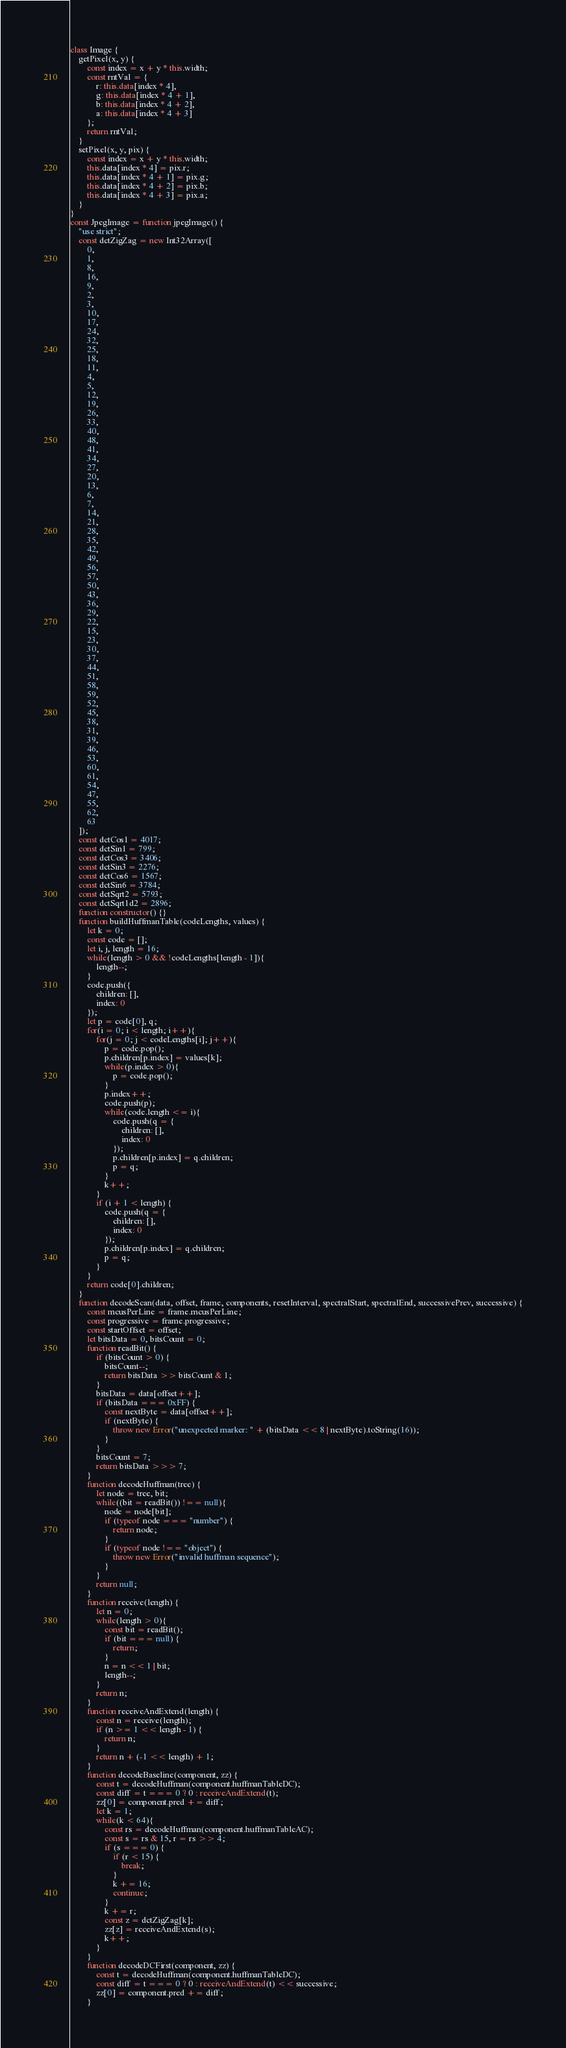Convert code to text. <code><loc_0><loc_0><loc_500><loc_500><_TypeScript_>class Image {
    getPixel(x, y) {
        const index = x + y * this.width;
        const rntVal = {
            r: this.data[index * 4],
            g: this.data[index * 4 + 1],
            b: this.data[index * 4 + 2],
            a: this.data[index * 4 + 3]
        };
        return rntVal;
    }
    setPixel(x, y, pix) {
        const index = x + y * this.width;
        this.data[index * 4] = pix.r;
        this.data[index * 4 + 1] = pix.g;
        this.data[index * 4 + 2] = pix.b;
        this.data[index * 4 + 3] = pix.a;
    }
}
const JpegImage = function jpegImage() {
    "use strict";
    const dctZigZag = new Int32Array([
        0,
        1,
        8,
        16,
        9,
        2,
        3,
        10,
        17,
        24,
        32,
        25,
        18,
        11,
        4,
        5,
        12,
        19,
        26,
        33,
        40,
        48,
        41,
        34,
        27,
        20,
        13,
        6,
        7,
        14,
        21,
        28,
        35,
        42,
        49,
        56,
        57,
        50,
        43,
        36,
        29,
        22,
        15,
        23,
        30,
        37,
        44,
        51,
        58,
        59,
        52,
        45,
        38,
        31,
        39,
        46,
        53,
        60,
        61,
        54,
        47,
        55,
        62,
        63
    ]);
    const dctCos1 = 4017;
    const dctSin1 = 799;
    const dctCos3 = 3406;
    const dctSin3 = 2276;
    const dctCos6 = 1567;
    const dctSin6 = 3784;
    const dctSqrt2 = 5793;
    const dctSqrt1d2 = 2896;
    function constructor() {}
    function buildHuffmanTable(codeLengths, values) {
        let k = 0;
        const code = [];
        let i, j, length = 16;
        while(length > 0 && !codeLengths[length - 1]){
            length--;
        }
        code.push({
            children: [],
            index: 0
        });
        let p = code[0], q;
        for(i = 0; i < length; i++){
            for(j = 0; j < codeLengths[i]; j++){
                p = code.pop();
                p.children[p.index] = values[k];
                while(p.index > 0){
                    p = code.pop();
                }
                p.index++;
                code.push(p);
                while(code.length <= i){
                    code.push(q = {
                        children: [],
                        index: 0
                    });
                    p.children[p.index] = q.children;
                    p = q;
                }
                k++;
            }
            if (i + 1 < length) {
                code.push(q = {
                    children: [],
                    index: 0
                });
                p.children[p.index] = q.children;
                p = q;
            }
        }
        return code[0].children;
    }
    function decodeScan(data, offset, frame, components, resetInterval, spectralStart, spectralEnd, successivePrev, successive) {
        const mcusPerLine = frame.mcusPerLine;
        const progressive = frame.progressive;
        const startOffset = offset;
        let bitsData = 0, bitsCount = 0;
        function readBit() {
            if (bitsCount > 0) {
                bitsCount--;
                return bitsData >> bitsCount & 1;
            }
            bitsData = data[offset++];
            if (bitsData === 0xFF) {
                const nextByte = data[offset++];
                if (nextByte) {
                    throw new Error("unexpected marker: " + (bitsData << 8 | nextByte).toString(16));
                }
            }
            bitsCount = 7;
            return bitsData >>> 7;
        }
        function decodeHuffman(tree) {
            let node = tree, bit;
            while((bit = readBit()) !== null){
                node = node[bit];
                if (typeof node === "number") {
                    return node;
                }
                if (typeof node !== "object") {
                    throw new Error("invalid huffman sequence");
                }
            }
            return null;
        }
        function receive(length) {
            let n = 0;
            while(length > 0){
                const bit = readBit();
                if (bit === null) {
                    return;
                }
                n = n << 1 | bit;
                length--;
            }
            return n;
        }
        function receiveAndExtend(length) {
            const n = receive(length);
            if (n >= 1 << length - 1) {
                return n;
            }
            return n + (-1 << length) + 1;
        }
        function decodeBaseline(component, zz) {
            const t = decodeHuffman(component.huffmanTableDC);
            const diff = t === 0 ? 0 : receiveAndExtend(t);
            zz[0] = component.pred += diff;
            let k = 1;
            while(k < 64){
                const rs = decodeHuffman(component.huffmanTableAC);
                const s = rs & 15, r = rs >> 4;
                if (s === 0) {
                    if (r < 15) {
                        break;
                    }
                    k += 16;
                    continue;
                }
                k += r;
                const z = dctZigZag[k];
                zz[z] = receiveAndExtend(s);
                k++;
            }
        }
        function decodeDCFirst(component, zz) {
            const t = decodeHuffman(component.huffmanTableDC);
            const diff = t === 0 ? 0 : receiveAndExtend(t) << successive;
            zz[0] = component.pred += diff;
        }</code> 